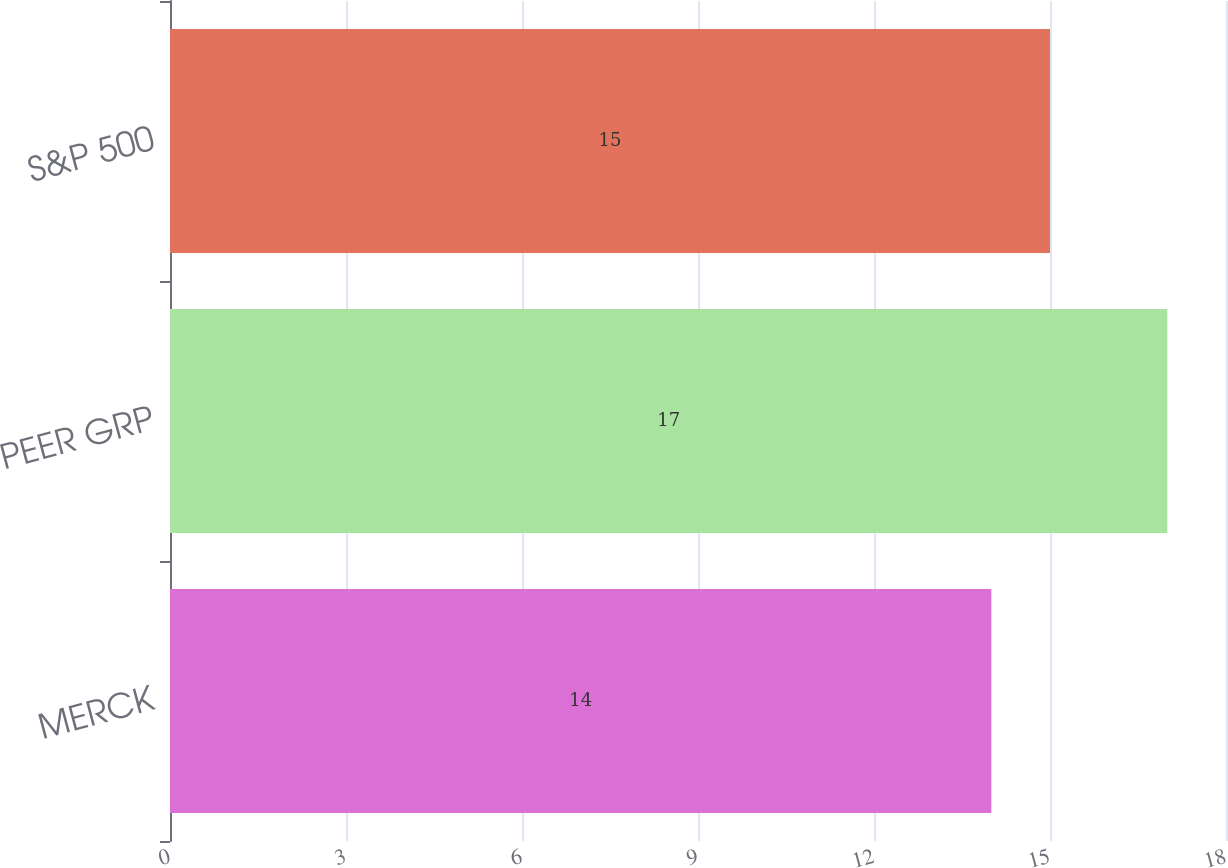Convert chart to OTSL. <chart><loc_0><loc_0><loc_500><loc_500><bar_chart><fcel>MERCK<fcel>PEER GRP<fcel>S&P 500<nl><fcel>14<fcel>17<fcel>15<nl></chart> 